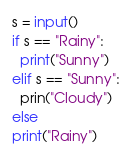Convert code to text. <code><loc_0><loc_0><loc_500><loc_500><_Python_>s = input()
if s == "Rainy":
  print("Sunny")
elif s == "Sunny":
  prin("Cloudy")
else
print("Rainy")
</code> 